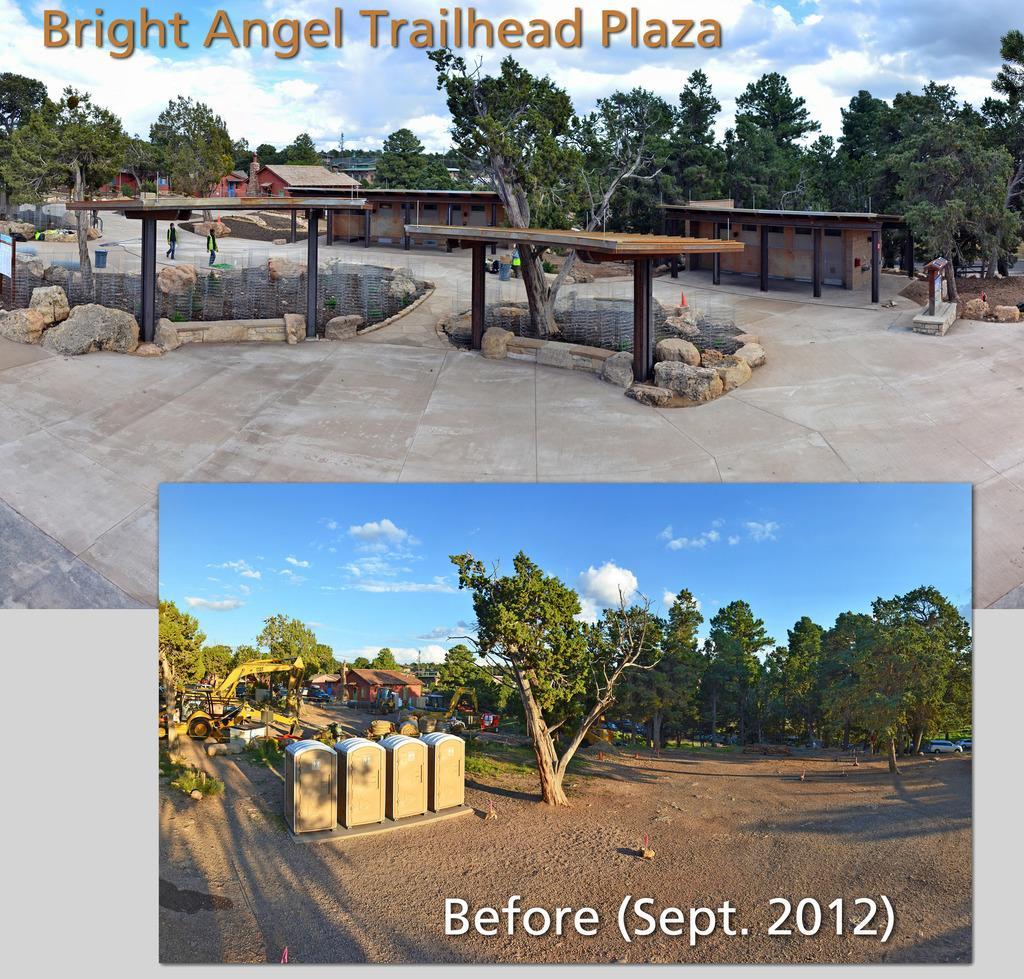Please provide a concise description of this image. In the image it is an animated picture, in the first image there are shelters, houses, trees and in the second image there are many trees and other objects. There is some text mentioned at the top left and bottom right corner of the image. 